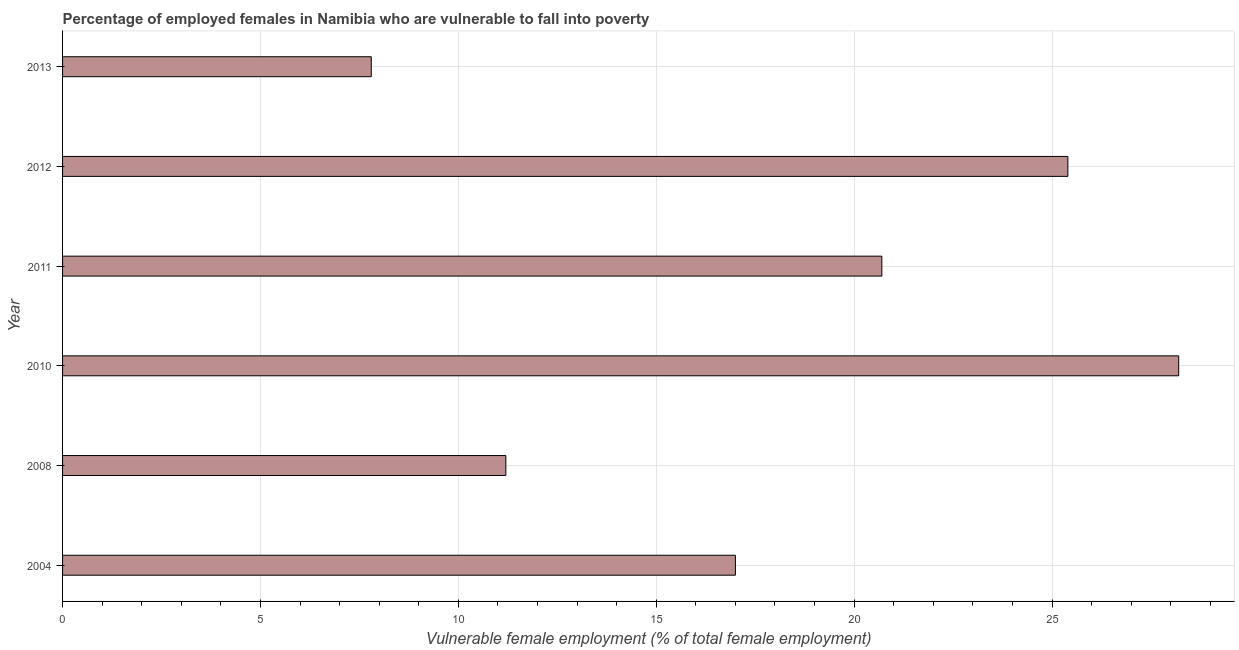Does the graph contain grids?
Provide a succinct answer. Yes. What is the title of the graph?
Your answer should be compact. Percentage of employed females in Namibia who are vulnerable to fall into poverty. What is the label or title of the X-axis?
Your response must be concise. Vulnerable female employment (% of total female employment). What is the percentage of employed females who are vulnerable to fall into poverty in 2008?
Ensure brevity in your answer.  11.2. Across all years, what is the maximum percentage of employed females who are vulnerable to fall into poverty?
Offer a very short reply. 28.2. Across all years, what is the minimum percentage of employed females who are vulnerable to fall into poverty?
Give a very brief answer. 7.8. In which year was the percentage of employed females who are vulnerable to fall into poverty maximum?
Your answer should be compact. 2010. What is the sum of the percentage of employed females who are vulnerable to fall into poverty?
Your answer should be very brief. 110.3. What is the average percentage of employed females who are vulnerable to fall into poverty per year?
Your answer should be compact. 18.38. What is the median percentage of employed females who are vulnerable to fall into poverty?
Offer a very short reply. 18.85. Do a majority of the years between 2008 and 2013 (inclusive) have percentage of employed females who are vulnerable to fall into poverty greater than 16 %?
Your answer should be very brief. Yes. What is the ratio of the percentage of employed females who are vulnerable to fall into poverty in 2008 to that in 2010?
Your response must be concise. 0.4. Is the percentage of employed females who are vulnerable to fall into poverty in 2004 less than that in 2010?
Make the answer very short. Yes. Is the difference between the percentage of employed females who are vulnerable to fall into poverty in 2004 and 2012 greater than the difference between any two years?
Your answer should be very brief. No. What is the difference between the highest and the second highest percentage of employed females who are vulnerable to fall into poverty?
Ensure brevity in your answer.  2.8. What is the difference between the highest and the lowest percentage of employed females who are vulnerable to fall into poverty?
Keep it short and to the point. 20.4. How many years are there in the graph?
Offer a terse response. 6. What is the difference between two consecutive major ticks on the X-axis?
Offer a very short reply. 5. What is the Vulnerable female employment (% of total female employment) of 2008?
Ensure brevity in your answer.  11.2. What is the Vulnerable female employment (% of total female employment) in 2010?
Provide a short and direct response. 28.2. What is the Vulnerable female employment (% of total female employment) of 2011?
Your response must be concise. 20.7. What is the Vulnerable female employment (% of total female employment) of 2012?
Offer a very short reply. 25.4. What is the Vulnerable female employment (% of total female employment) of 2013?
Make the answer very short. 7.8. What is the difference between the Vulnerable female employment (% of total female employment) in 2004 and 2008?
Your answer should be compact. 5.8. What is the difference between the Vulnerable female employment (% of total female employment) in 2004 and 2012?
Your answer should be very brief. -8.4. What is the difference between the Vulnerable female employment (% of total female employment) in 2004 and 2013?
Your answer should be compact. 9.2. What is the difference between the Vulnerable female employment (% of total female employment) in 2008 and 2012?
Give a very brief answer. -14.2. What is the difference between the Vulnerable female employment (% of total female employment) in 2008 and 2013?
Your answer should be compact. 3.4. What is the difference between the Vulnerable female employment (% of total female employment) in 2010 and 2012?
Ensure brevity in your answer.  2.8. What is the difference between the Vulnerable female employment (% of total female employment) in 2010 and 2013?
Offer a terse response. 20.4. What is the difference between the Vulnerable female employment (% of total female employment) in 2011 and 2012?
Keep it short and to the point. -4.7. What is the difference between the Vulnerable female employment (% of total female employment) in 2011 and 2013?
Your answer should be compact. 12.9. What is the ratio of the Vulnerable female employment (% of total female employment) in 2004 to that in 2008?
Make the answer very short. 1.52. What is the ratio of the Vulnerable female employment (% of total female employment) in 2004 to that in 2010?
Offer a terse response. 0.6. What is the ratio of the Vulnerable female employment (% of total female employment) in 2004 to that in 2011?
Keep it short and to the point. 0.82. What is the ratio of the Vulnerable female employment (% of total female employment) in 2004 to that in 2012?
Make the answer very short. 0.67. What is the ratio of the Vulnerable female employment (% of total female employment) in 2004 to that in 2013?
Your answer should be very brief. 2.18. What is the ratio of the Vulnerable female employment (% of total female employment) in 2008 to that in 2010?
Your response must be concise. 0.4. What is the ratio of the Vulnerable female employment (% of total female employment) in 2008 to that in 2011?
Provide a succinct answer. 0.54. What is the ratio of the Vulnerable female employment (% of total female employment) in 2008 to that in 2012?
Make the answer very short. 0.44. What is the ratio of the Vulnerable female employment (% of total female employment) in 2008 to that in 2013?
Provide a succinct answer. 1.44. What is the ratio of the Vulnerable female employment (% of total female employment) in 2010 to that in 2011?
Your answer should be compact. 1.36. What is the ratio of the Vulnerable female employment (% of total female employment) in 2010 to that in 2012?
Ensure brevity in your answer.  1.11. What is the ratio of the Vulnerable female employment (% of total female employment) in 2010 to that in 2013?
Your answer should be compact. 3.62. What is the ratio of the Vulnerable female employment (% of total female employment) in 2011 to that in 2012?
Give a very brief answer. 0.81. What is the ratio of the Vulnerable female employment (% of total female employment) in 2011 to that in 2013?
Give a very brief answer. 2.65. What is the ratio of the Vulnerable female employment (% of total female employment) in 2012 to that in 2013?
Make the answer very short. 3.26. 